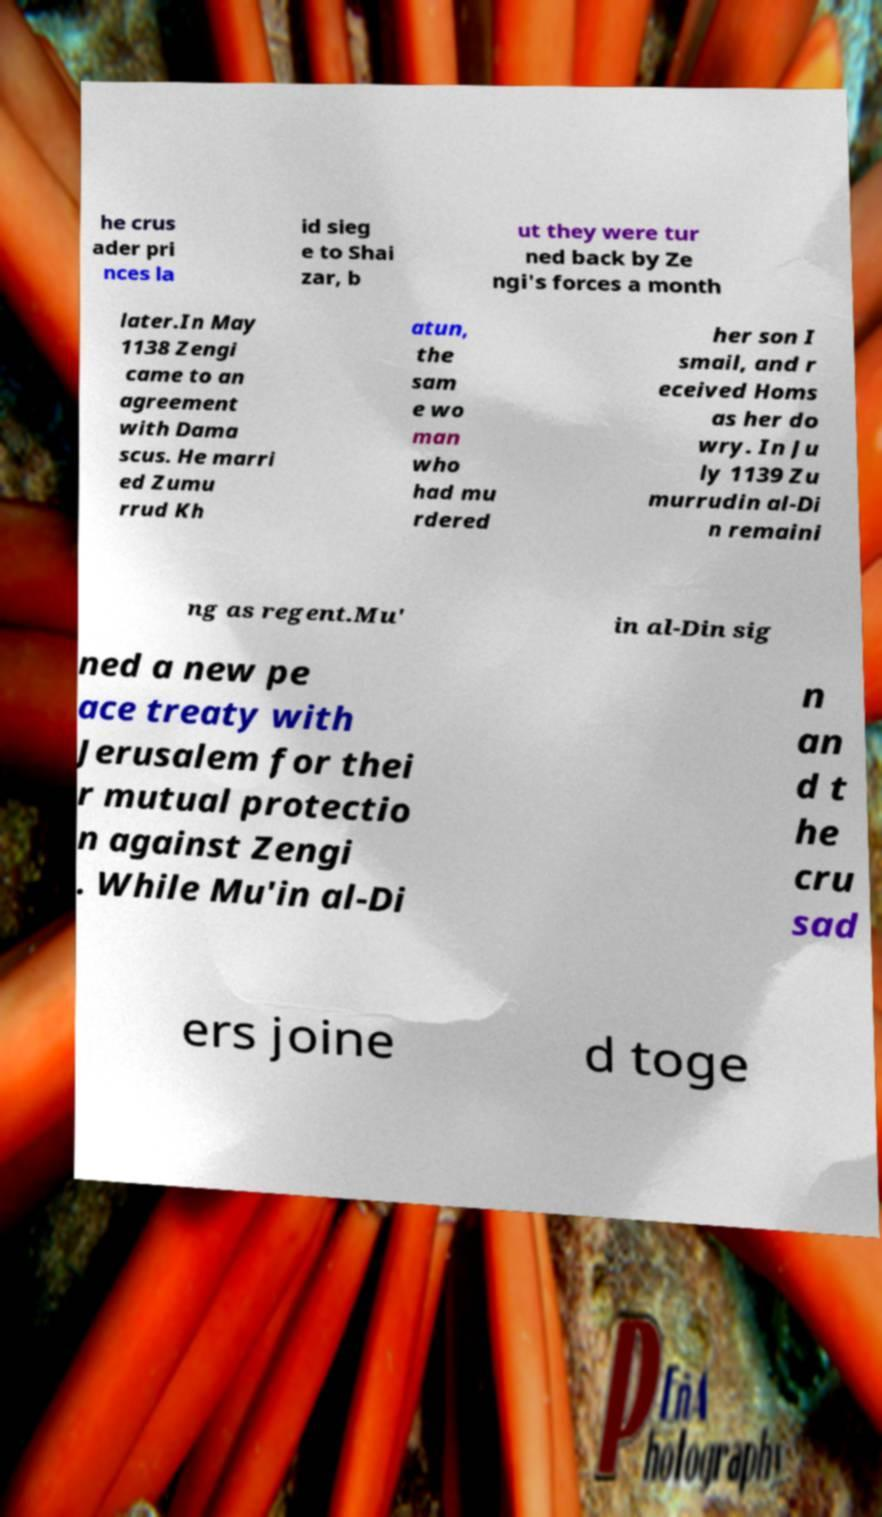Could you assist in decoding the text presented in this image and type it out clearly? he crus ader pri nces la id sieg e to Shai zar, b ut they were tur ned back by Ze ngi's forces a month later.In May 1138 Zengi came to an agreement with Dama scus. He marri ed Zumu rrud Kh atun, the sam e wo man who had mu rdered her son I smail, and r eceived Homs as her do wry. In Ju ly 1139 Zu murrudin al-Di n remaini ng as regent.Mu' in al-Din sig ned a new pe ace treaty with Jerusalem for thei r mutual protectio n against Zengi . While Mu'in al-Di n an d t he cru sad ers joine d toge 